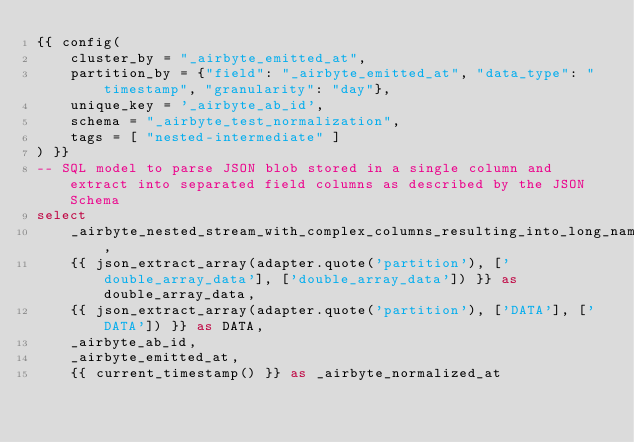Convert code to text. <code><loc_0><loc_0><loc_500><loc_500><_SQL_>{{ config(
    cluster_by = "_airbyte_emitted_at",
    partition_by = {"field": "_airbyte_emitted_at", "data_type": "timestamp", "granularity": "day"},
    unique_key = '_airbyte_ab_id',
    schema = "_airbyte_test_normalization",
    tags = [ "nested-intermediate" ]
) }}
-- SQL model to parse JSON blob stored in a single column and extract into separated field columns as described by the JSON Schema
select
    _airbyte_nested_stream_with_complex_columns_resulting_into_long_names_hashid,
    {{ json_extract_array(adapter.quote('partition'), ['double_array_data'], ['double_array_data']) }} as double_array_data,
    {{ json_extract_array(adapter.quote('partition'), ['DATA'], ['DATA']) }} as DATA,
    _airbyte_ab_id,
    _airbyte_emitted_at,
    {{ current_timestamp() }} as _airbyte_normalized_at</code> 